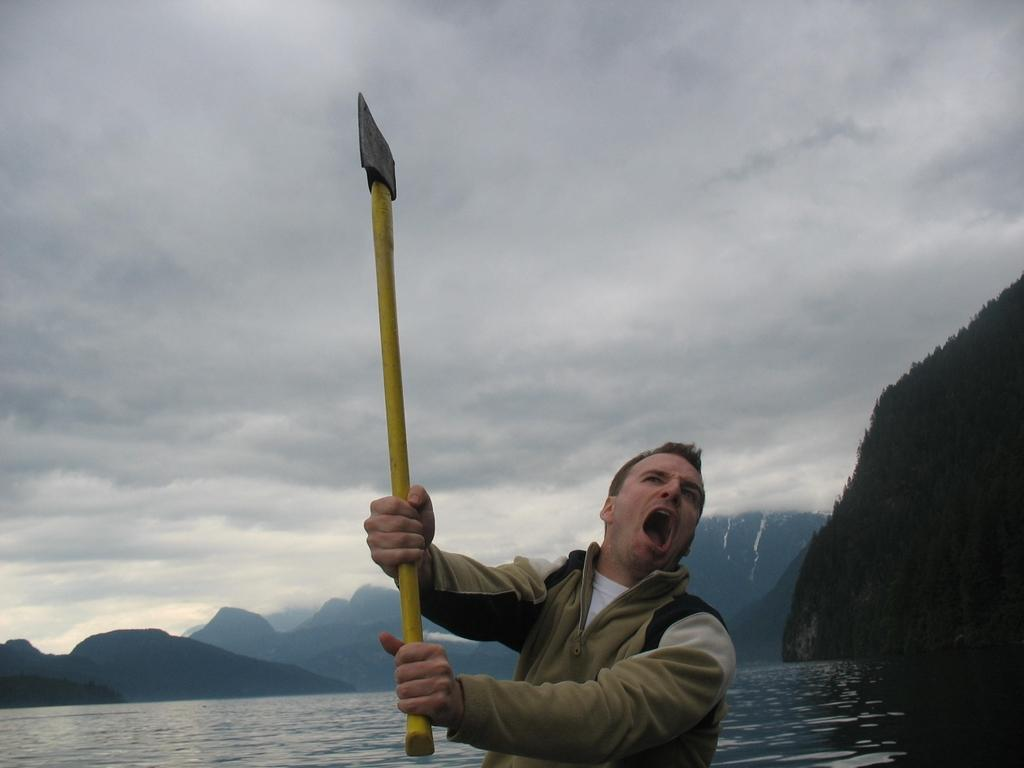Who is present in the image? There is a man in the image. What is the man holding in the image? The man is holding an axe. What is the man wearing in the image? The man is wearing a sweater. What can be seen at the bottom of the image? There is water at the bottom of the image. What type of landscape is visible on the right side of the image? There are hills on the right side of the image. How would you describe the weather based on the image? The sky is cloudy at the top of the image, suggesting a potentially overcast or cloudy day. How many lizards are present in the image? There are no lizards present in the image. Can you compare the man's sweater to another sweater in the image? There is only one man and one sweater present in the image, so there is no other sweater to compare it to. 